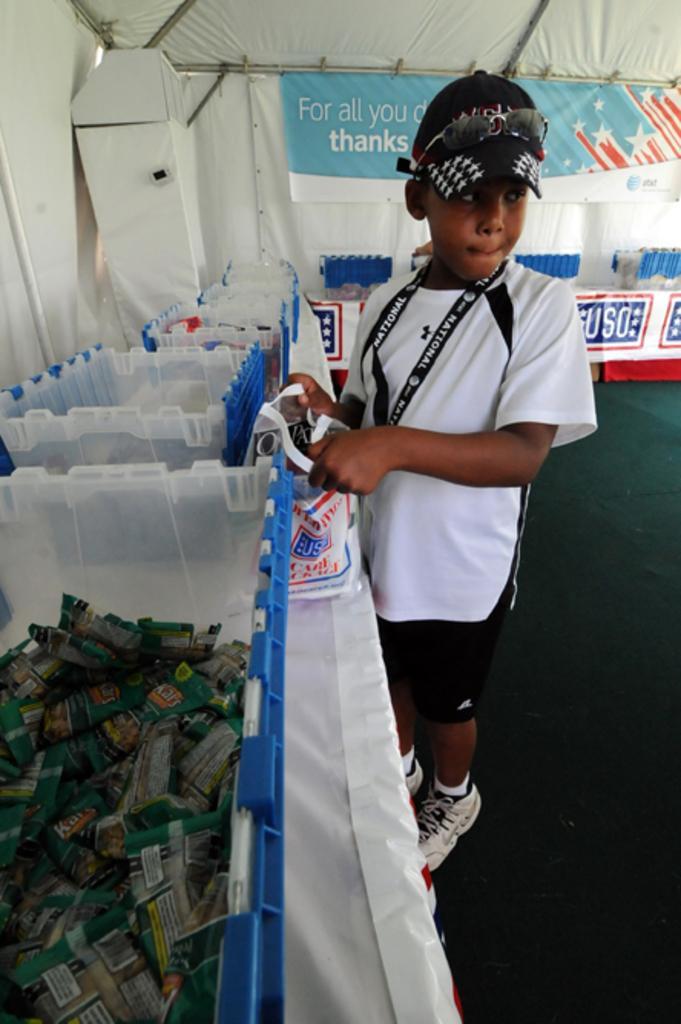Describe this image in one or two sentences. In this image I can see a boy in white t shirt wearing a black cap. I can see he is holding a carry bag in his hand. In the background I can see tent and some containers. 